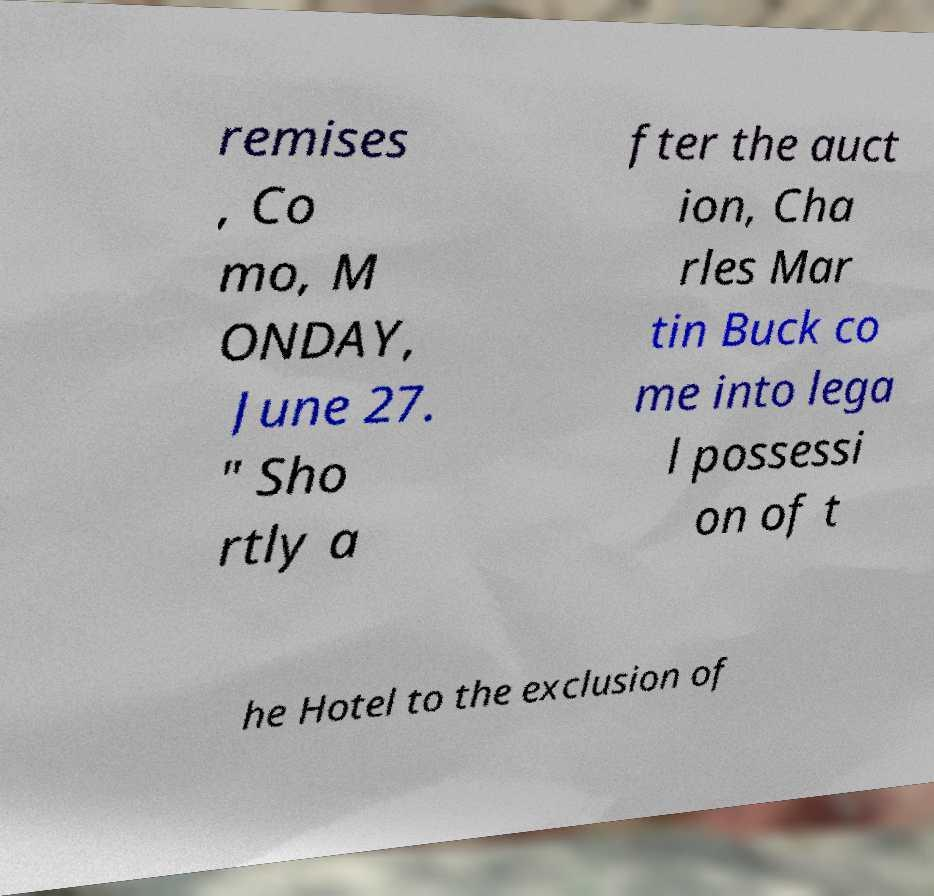What messages or text are displayed in this image? I need them in a readable, typed format. remises , Co mo, M ONDAY, June 27. " Sho rtly a fter the auct ion, Cha rles Mar tin Buck co me into lega l possessi on of t he Hotel to the exclusion of 